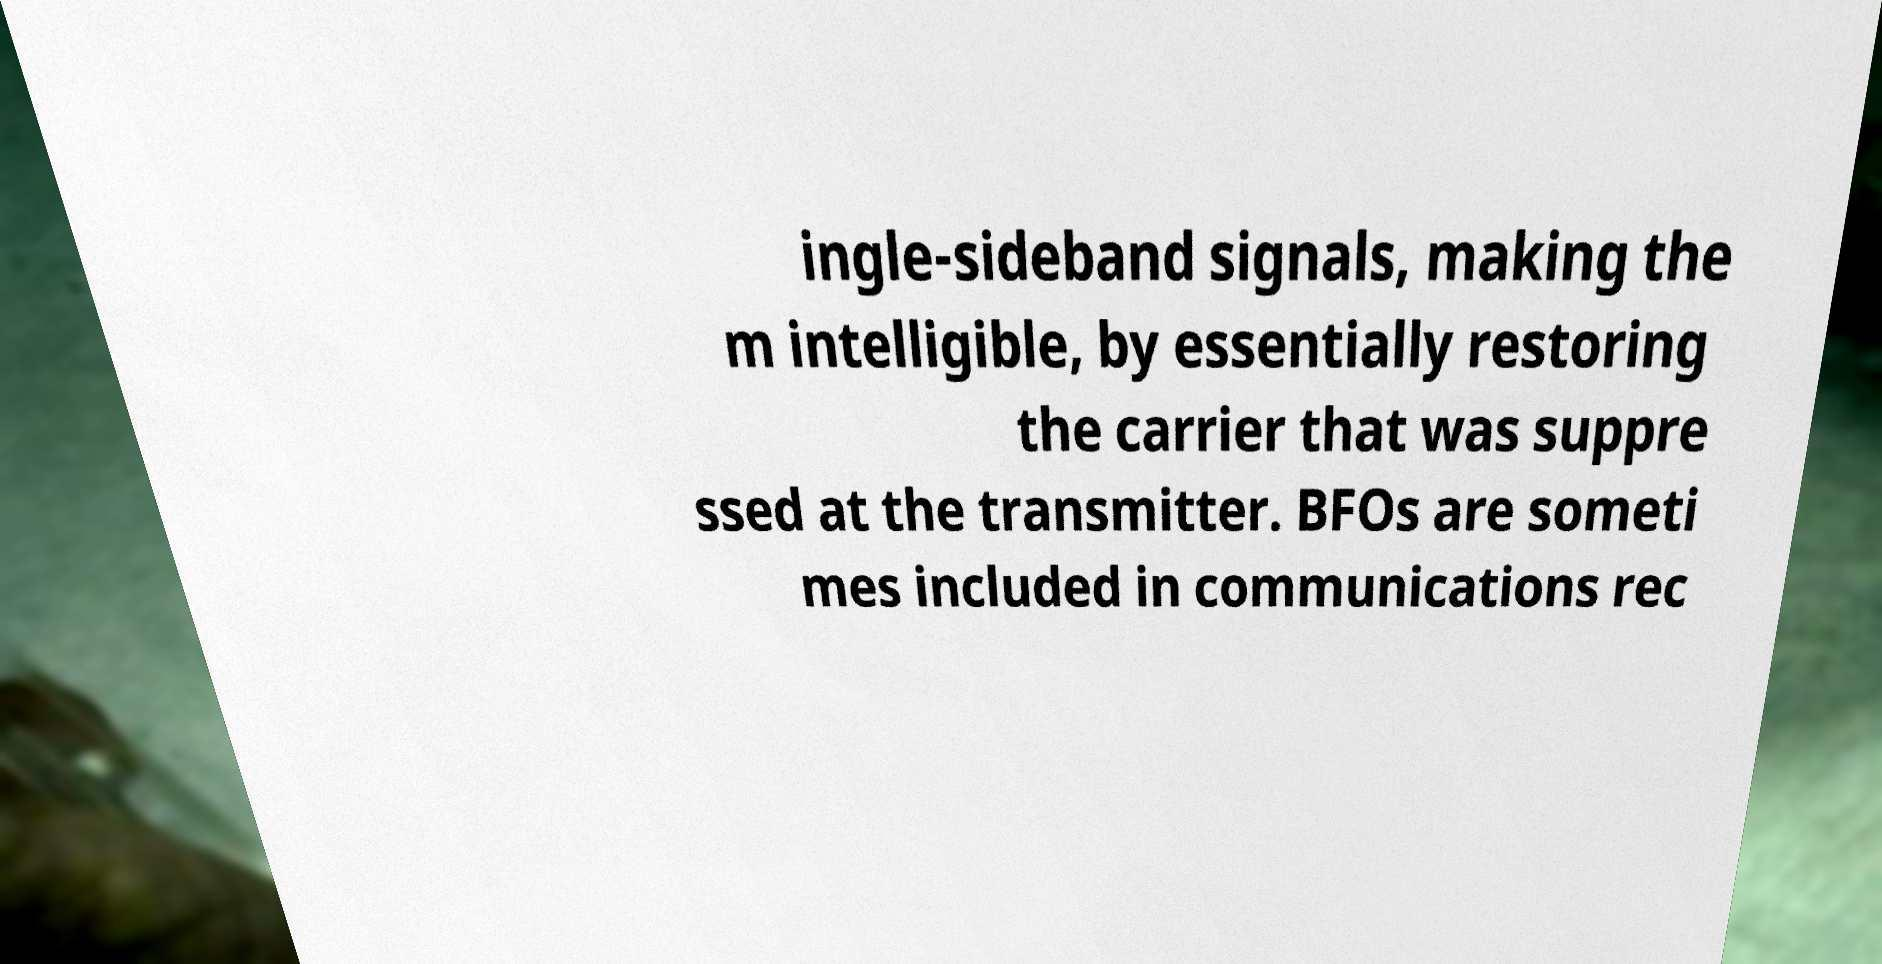I need the written content from this picture converted into text. Can you do that? ingle-sideband signals, making the m intelligible, by essentially restoring the carrier that was suppre ssed at the transmitter. BFOs are someti mes included in communications rec 